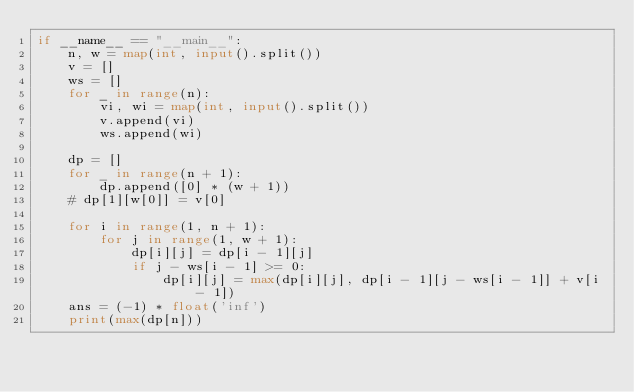<code> <loc_0><loc_0><loc_500><loc_500><_Python_>if __name__ == "__main__":
    n, w = map(int, input().split())
    v = []
    ws = []
    for _ in range(n):
        vi, wi = map(int, input().split())
        v.append(vi)
        ws.append(wi)
    
    dp = []
    for _ in range(n + 1):
        dp.append([0] * (w + 1))
    # dp[1][w[0]] = v[0]
    
    for i in range(1, n + 1):
        for j in range(1, w + 1):
            dp[i][j] = dp[i - 1][j]
            if j - ws[i - 1] >= 0:
                dp[i][j] = max(dp[i][j], dp[i - 1][j - ws[i - 1]] + v[i - 1])
    ans = (-1) * float('inf')
    print(max(dp[n]))
</code> 